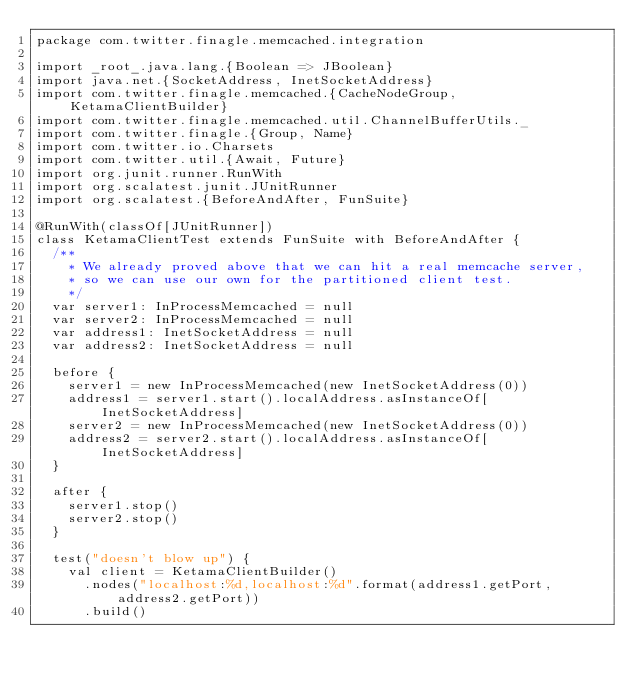Convert code to text. <code><loc_0><loc_0><loc_500><loc_500><_Scala_>package com.twitter.finagle.memcached.integration

import _root_.java.lang.{Boolean => JBoolean}
import java.net.{SocketAddress, InetSocketAddress}
import com.twitter.finagle.memcached.{CacheNodeGroup, KetamaClientBuilder}
import com.twitter.finagle.memcached.util.ChannelBufferUtils._
import com.twitter.finagle.{Group, Name}
import com.twitter.io.Charsets
import com.twitter.util.{Await, Future}
import org.junit.runner.RunWith
import org.scalatest.junit.JUnitRunner
import org.scalatest.{BeforeAndAfter, FunSuite}

@RunWith(classOf[JUnitRunner])
class KetamaClientTest extends FunSuite with BeforeAndAfter {
  /**
    * We already proved above that we can hit a real memcache server,
    * so we can use our own for the partitioned client test.
    */
  var server1: InProcessMemcached = null
  var server2: InProcessMemcached = null
  var address1: InetSocketAddress = null
  var address2: InetSocketAddress = null

  before {
    server1 = new InProcessMemcached(new InetSocketAddress(0))
    address1 = server1.start().localAddress.asInstanceOf[InetSocketAddress]
    server2 = new InProcessMemcached(new InetSocketAddress(0))
    address2 = server2.start().localAddress.asInstanceOf[InetSocketAddress]
  }

  after {
    server1.stop()
    server2.stop()
  }

  test("doesn't blow up") {
    val client = KetamaClientBuilder()
      .nodes("localhost:%d,localhost:%d".format(address1.getPort, address2.getPort))
      .build()
</code> 